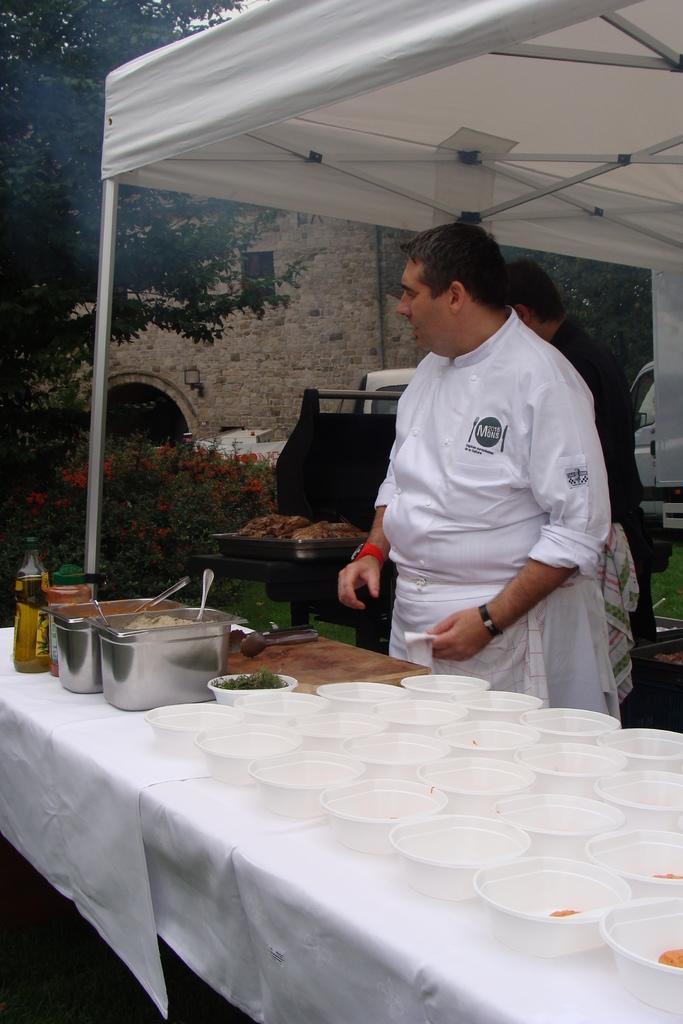Can you describe this image briefly? This image consists of a man who is standing on the right side. He is wearing white color dress. In front of him there is a table, on that table there are so many white bowls, bottle and spoons. In the top there is a tent, on the left side there is a tree and shrubs. Behind that tree there is a building. 